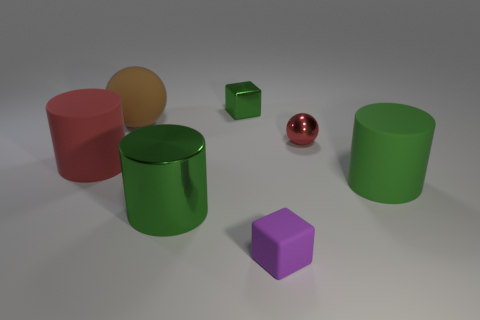Are there any other things that have the same shape as the red metal thing?
Provide a succinct answer. Yes. What number of brown objects are there?
Your response must be concise. 1. How many green objects are either large rubber cylinders or tiny metallic blocks?
Provide a succinct answer. 2. Are the red object that is on the right side of the metallic cylinder and the green block made of the same material?
Make the answer very short. Yes. What number of other things are the same material as the tiny red thing?
Your answer should be compact. 2. What material is the large sphere?
Provide a succinct answer. Rubber. There is a red object that is on the left side of the big brown ball; what size is it?
Offer a very short reply. Large. What number of rubber balls are in front of the green shiny thing that is in front of the tiny green shiny block?
Your answer should be very brief. 0. There is a matte object that is in front of the green matte thing; does it have the same shape as the tiny metal object that is on the right side of the tiny purple block?
Keep it short and to the point. No. What number of big cylinders are both to the right of the rubber ball and on the left side of the green rubber cylinder?
Offer a very short reply. 1. 